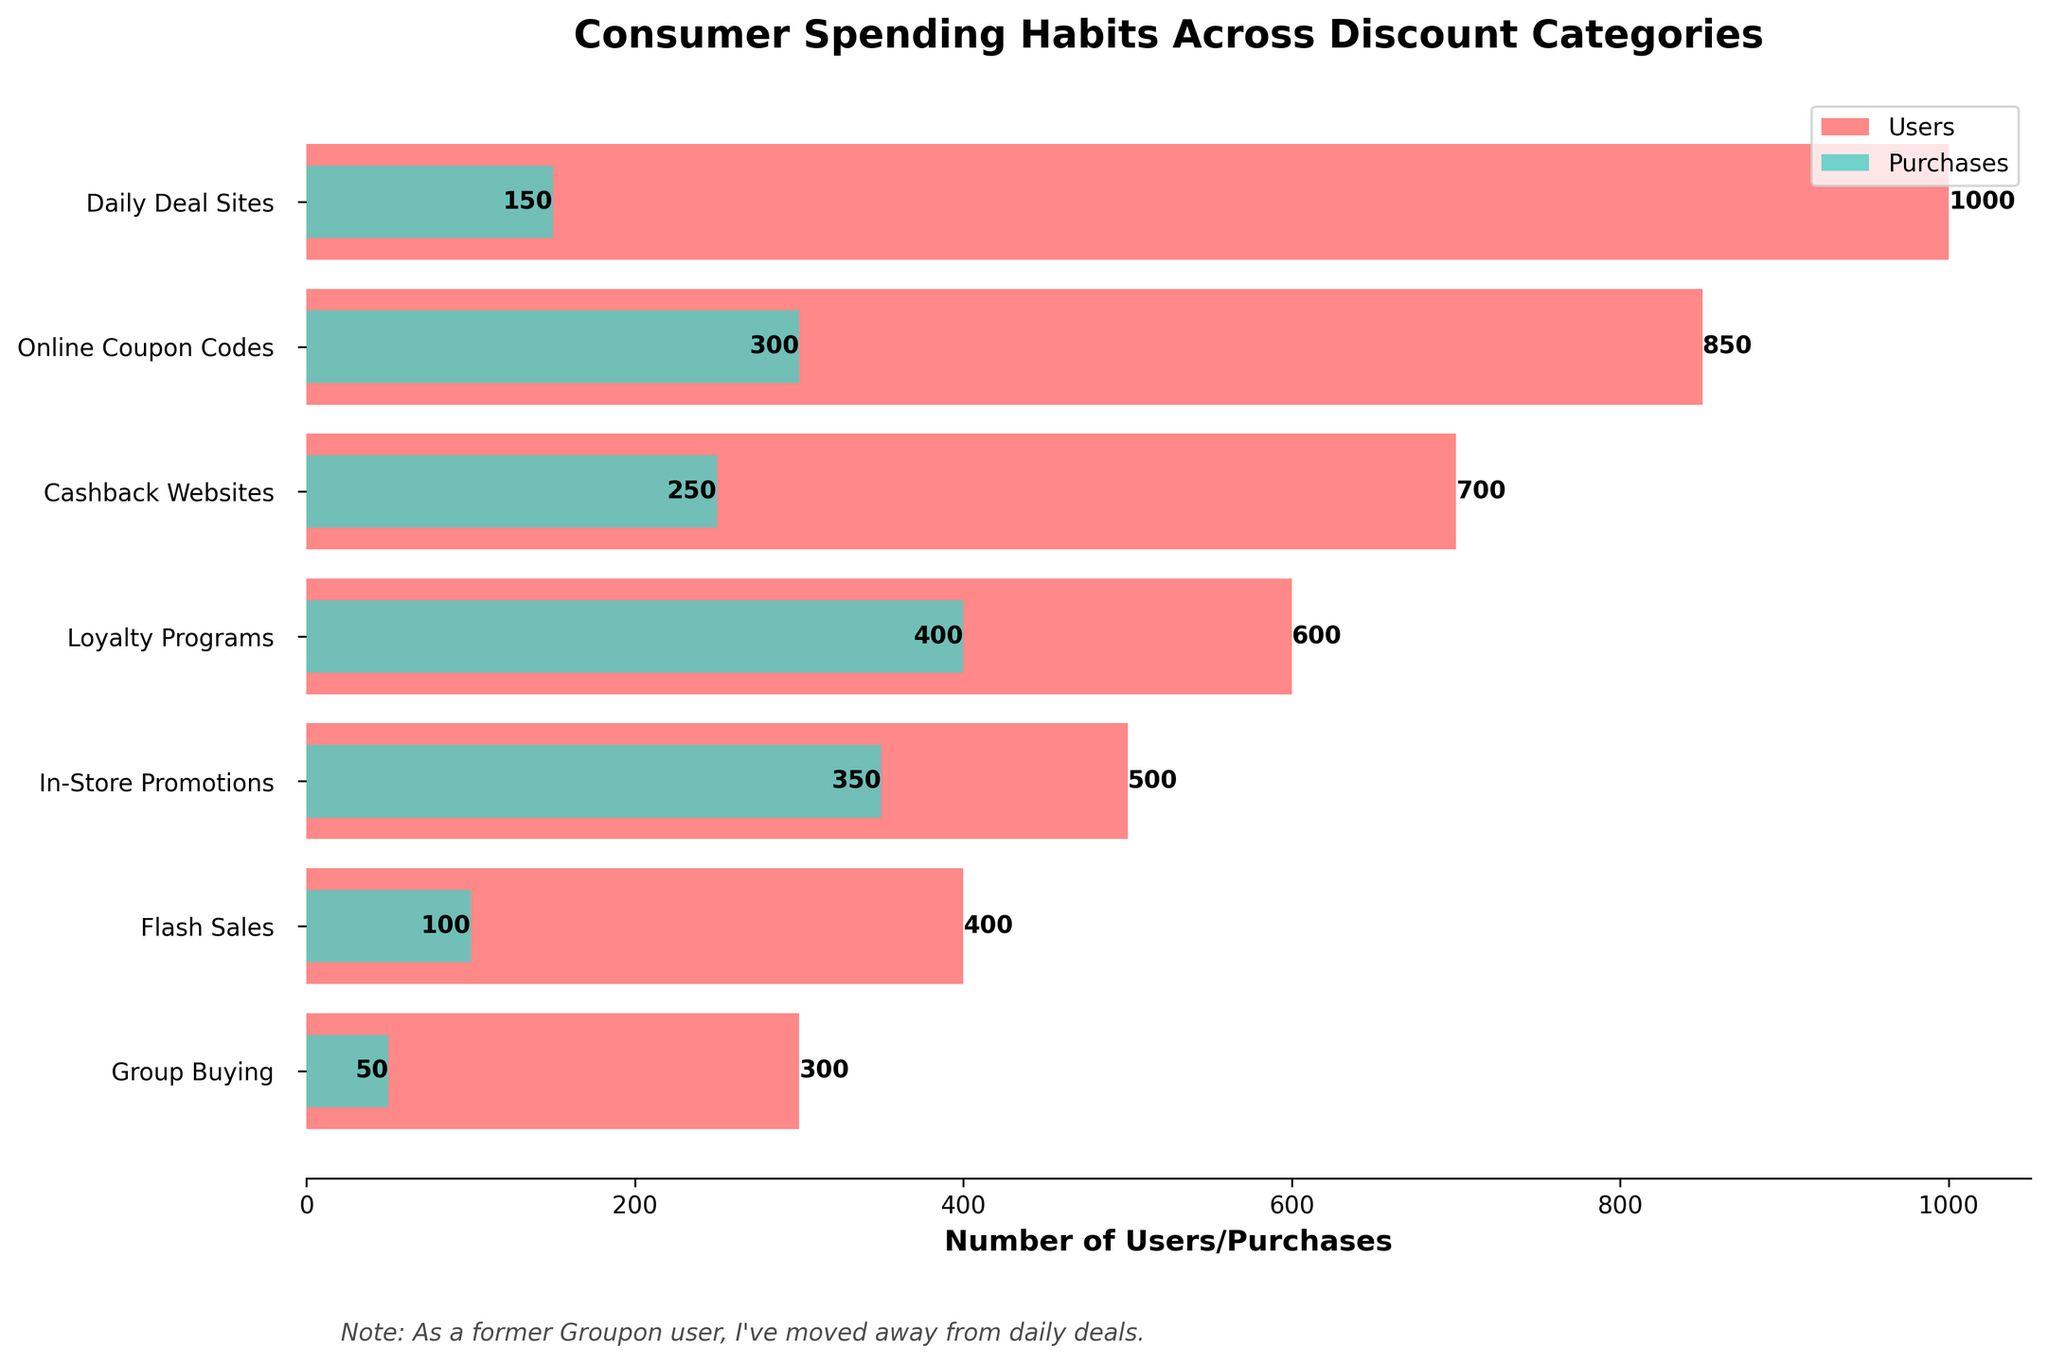what is the title of the chart? The title of the chart is written at the top of the figure and typically summarizes the main content in a few words.
Answer: Consumer Spending Habits Across Discount Categories which discount category has the most users? To find the discount category with the most users, look at the longest bar in the 'Users' series. The length of the bar represents the number of users.
Answer: Daily Deal Sites how many purchases are made through loyalty programs? Find the bar labeled 'Loyalty Programs' and read the value next to the purchases part of the bar.
Answer: 400 what is the difference in the number of users between daily deal sites and group buying? To find the difference, subtract the number of users in 'Group Buying' from the number of users in 'Daily Deal Sites'. The 'Daily Deal Sites' has 1000 users and 'Group Buying' has 300 users.
Answer: 700 which discount category has the least number of purchases? Look for the bar in the 'Purchases' series that is the shortest. The shortest bar represents the least number of purchases.
Answer: Group Buying how many fewer purchases are there in in-store promotions compared to loyalty programs? To find how many fewer, subtract the number of purchases in 'In-Store Promotions' from the number of purchases in 'Loyalty Programs'. 'In-Store Promotions' has 350 purchases and 'Loyalty Programs' has 400 purchases.
Answer: 50 what color represents the 'Users' data in the chart? Identify the color that corresponds to the 'Users' bar in the legend.
Answer: Red what is the average number of purchases across all discount categories? Add the number of purchases for all categories and then divide by the number of categories. (150 + 300 + 250 + 400 + 350 + 100 + 50) / 7 = 1600 / 7
Answer: Approximately 228.57 what proportion of users make purchases in online coupon codes? Divide the number of purchases by the number of users for the 'Online Coupon Codes' category and then multiply by 100 to get the percentage. (300/850) * 100
Answer: Approximately 35.29% which two categories have a significant drop in users to purchases? Compare the steepness of decline from bars representing users to purchases for each category. Identify the two steepest declines.
Answer: Daily Deal Sites and Flash Sales 